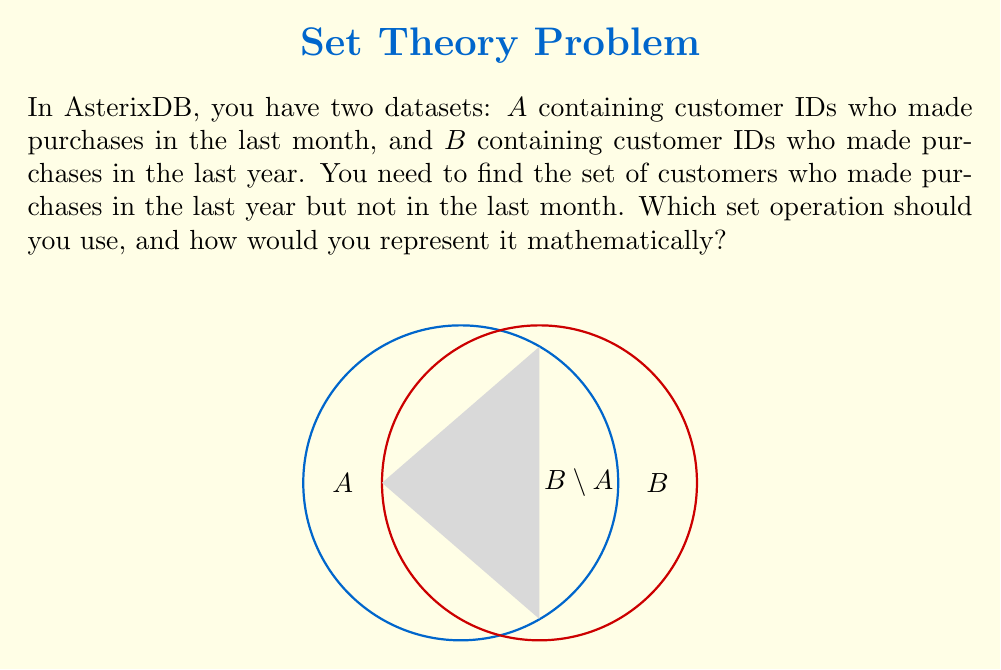Provide a solution to this math problem. To solve this problem, we need to understand the concept of relative complement in set theory and how it applies to our datasets in AsterixDB.

1. The relative complement of $A$ with respect to $B$, denoted as $B \setminus A$, represents the elements that are in $B$ but not in $A$.

2. In our case:
   - $A$ = customers who made purchases in the last month
   - $B$ = customers who made purchases in the last year

3. We want to find customers who made purchases in the last year (set $B$) but not in the last month (set $A$).

4. This operation can be represented mathematically as:

   $$B \setminus A = \{x \in B | x \notin A\}$$

5. In AsterixDB, this operation can be performed using the EXCEPT clause in AQL (AsterixDB Query Language).

6. The query structure would look like:
   ```
   SELECT B.customer_id
   FROM Dataset_B AS B
   EXCEPT
   SELECT A.customer_id
   FROM Dataset_A AS A
   ```

This operation will return the set of customer IDs that are in $B$ (last year's customers) but not in $A$ (last month's customers), effectively giving us the relative complement $B \setminus A$.
Answer: Relative complement: $B \setminus A$ 